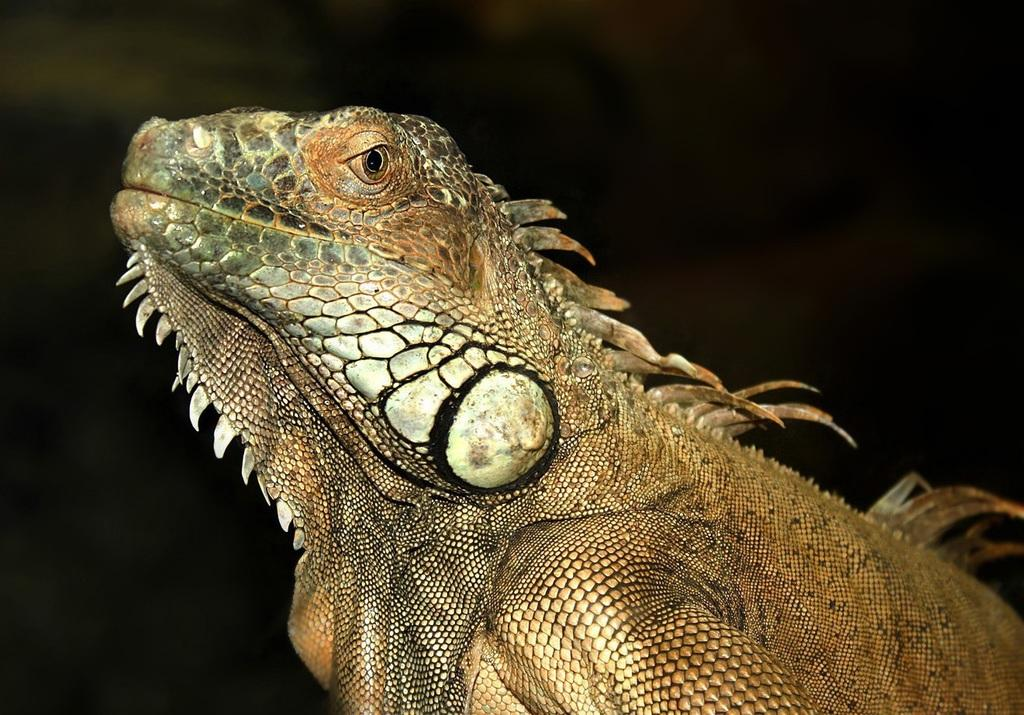What type of animal is in the image? There is a green iguana in the image. Can you describe the background of the image? The background of the image is blurry. How many rabbits can be seen playing with dinosaurs in the image? There are no rabbits or dinosaurs present in the image; it features a green iguana. 